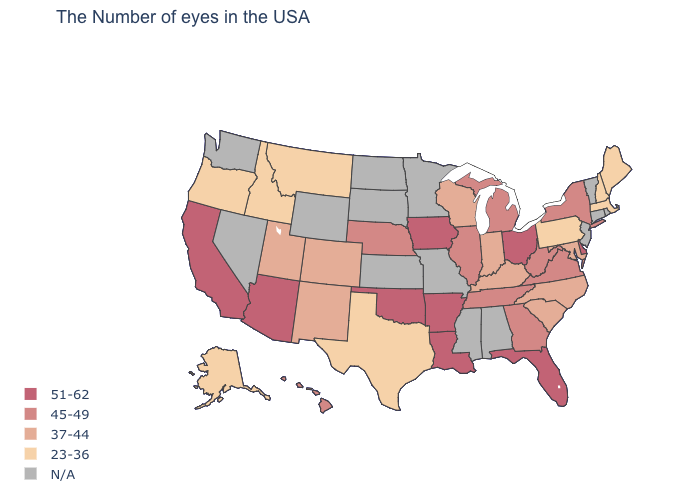Which states have the lowest value in the USA?
Write a very short answer. Maine, Massachusetts, New Hampshire, Pennsylvania, Texas, Montana, Idaho, Oregon, Alaska. What is the highest value in the South ?
Be succinct. 51-62. What is the value of New Mexico?
Concise answer only. 37-44. What is the value of Illinois?
Answer briefly. 45-49. Which states hav the highest value in the West?
Be succinct. Arizona, California. Does Massachusetts have the lowest value in the USA?
Write a very short answer. Yes. Name the states that have a value in the range 45-49?
Answer briefly. New York, Virginia, West Virginia, Georgia, Michigan, Tennessee, Illinois, Nebraska, Hawaii. What is the value of Washington?
Short answer required. N/A. What is the lowest value in states that border Colorado?
Write a very short answer. 37-44. Name the states that have a value in the range 23-36?
Be succinct. Maine, Massachusetts, New Hampshire, Pennsylvania, Texas, Montana, Idaho, Oregon, Alaska. Name the states that have a value in the range 51-62?
Keep it brief. Delaware, Ohio, Florida, Louisiana, Arkansas, Iowa, Oklahoma, Arizona, California. Which states hav the highest value in the West?
Write a very short answer. Arizona, California. 